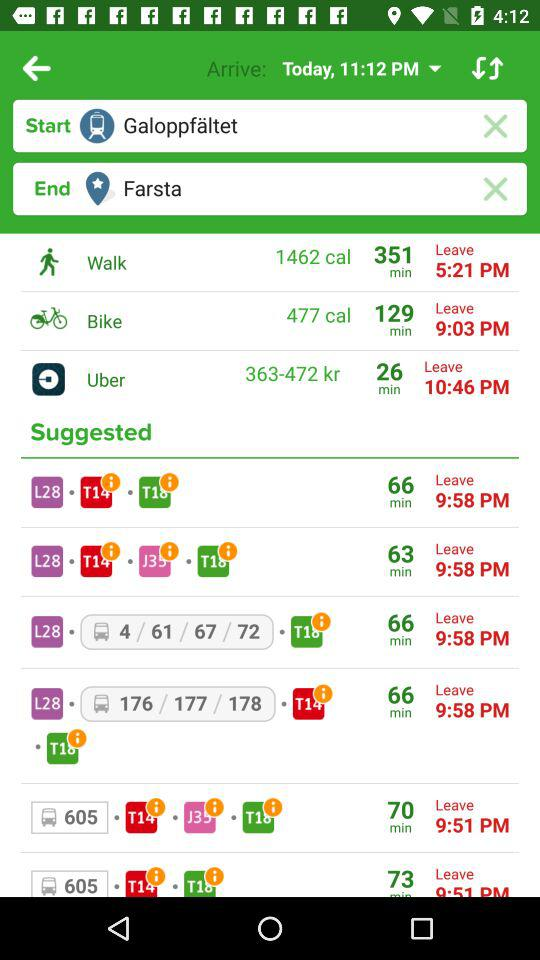What is the time to leave if you walk to your destination? The time is 5:21 PM. 